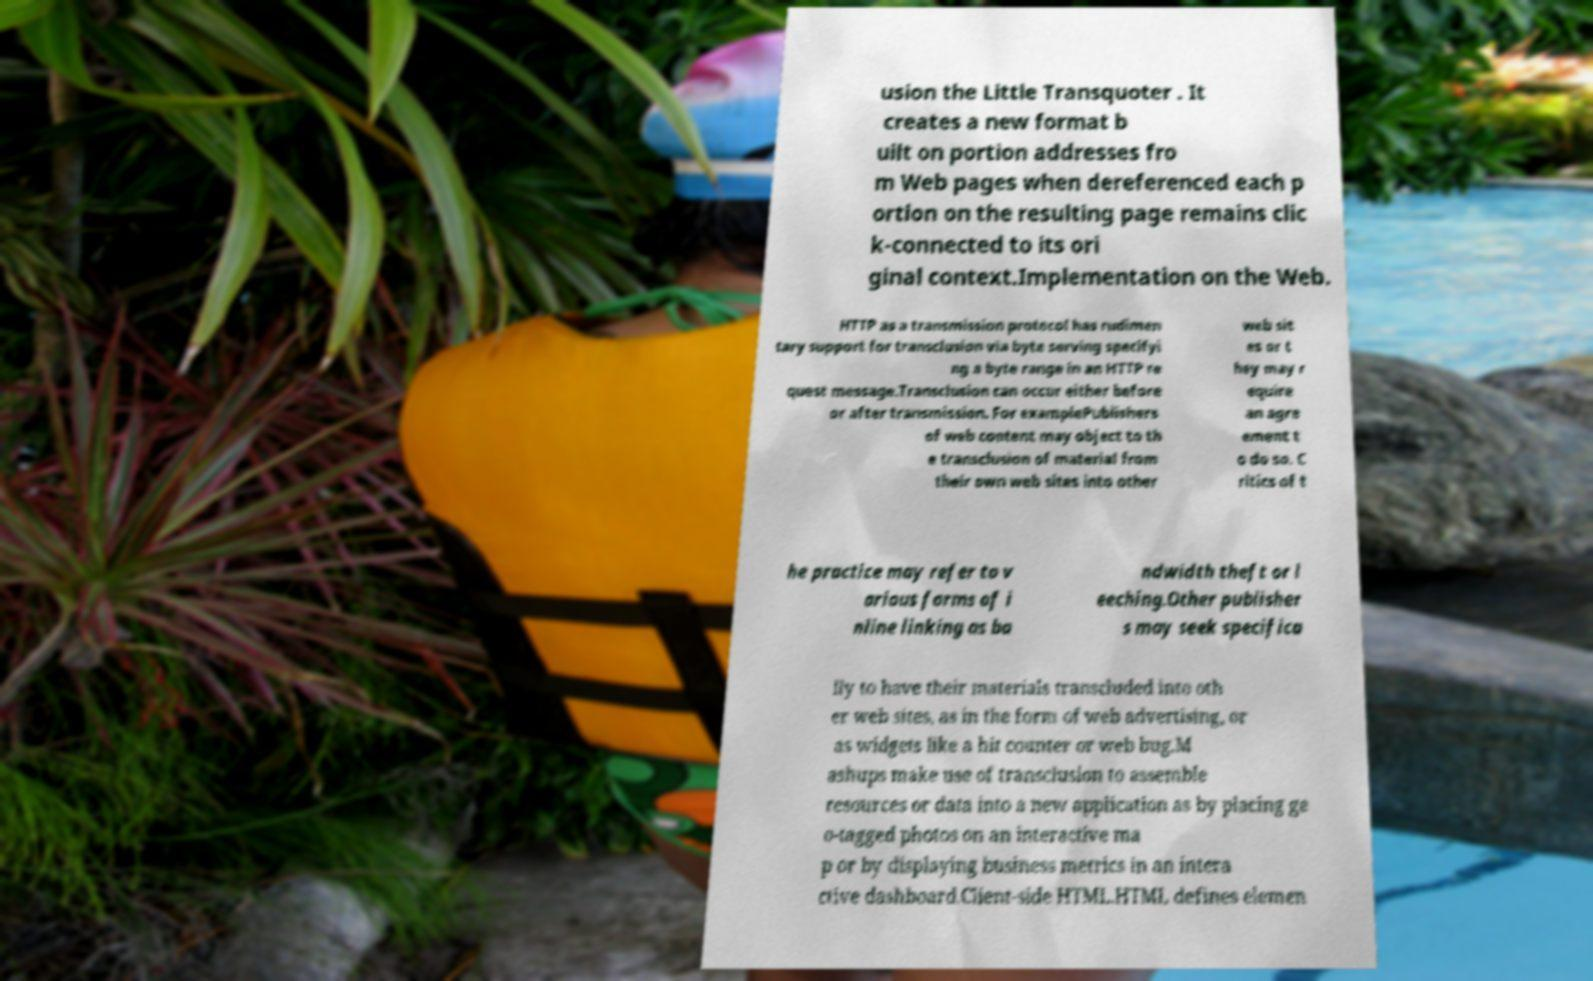Could you assist in decoding the text presented in this image and type it out clearly? usion the Little Transquoter . It creates a new format b uilt on portion addresses fro m Web pages when dereferenced each p ortion on the resulting page remains clic k-connected to its ori ginal context.Implementation on the Web. HTTP as a transmission protocol has rudimen tary support for transclusion via byte serving specifyi ng a byte range in an HTTP re quest message.Transclusion can occur either before or after transmission. For examplePublishers of web content may object to th e transclusion of material from their own web sites into other web sit es or t hey may r equire an agre ement t o do so. C ritics of t he practice may refer to v arious forms of i nline linking as ba ndwidth theft or l eeching.Other publisher s may seek specifica lly to have their materials transcluded into oth er web sites, as in the form of web advertising, or as widgets like a hit counter or web bug.M ashups make use of transclusion to assemble resources or data into a new application as by placing ge o-tagged photos on an interactive ma p or by displaying business metrics in an intera ctive dashboard.Client-side HTML.HTML defines elemen 